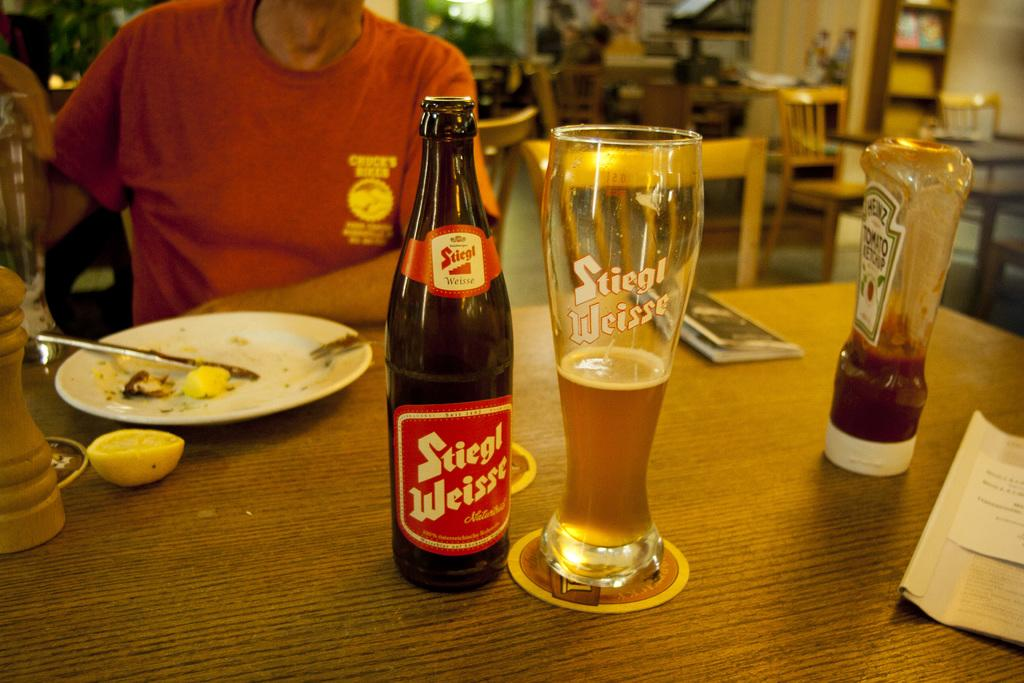<image>
Give a short and clear explanation of the subsequent image. Someone sitting at a table with a bottle of Steigl Weisse beer which has been poured into a glass, and a bottle of Heinz ketchup. 